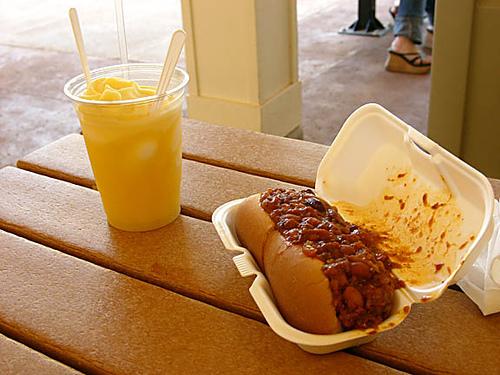Are there beans on the hot dog?
Keep it brief. Yes. Is that a chili dog?
Answer briefly. Yes. Why does the beverage need a spoon?
Write a very short answer. Frozen. 